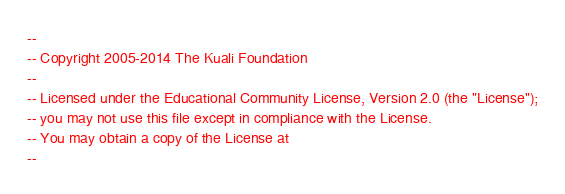Convert code to text. <code><loc_0><loc_0><loc_500><loc_500><_SQL_>--
-- Copyright 2005-2014 The Kuali Foundation
--
-- Licensed under the Educational Community License, Version 2.0 (the "License");
-- you may not use this file except in compliance with the License.
-- You may obtain a copy of the License at
--</code> 